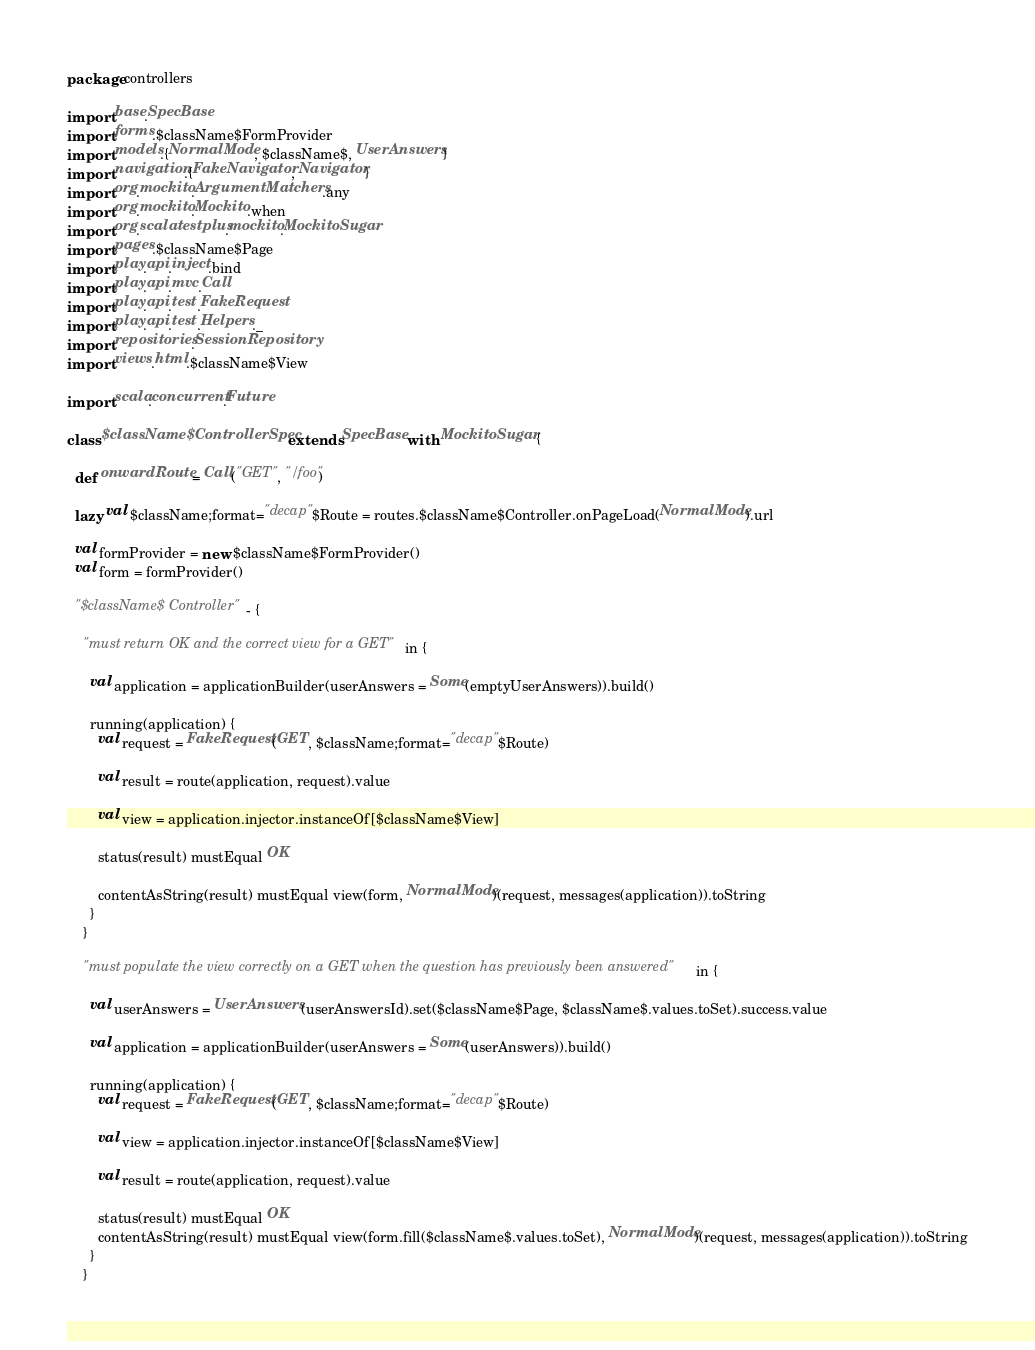<code> <loc_0><loc_0><loc_500><loc_500><_Scala_>package controllers

import base.SpecBase
import forms.$className$FormProvider
import models.{NormalMode, $className$, UserAnswers}
import navigation.{FakeNavigator, Navigator}
import org.mockito.ArgumentMatchers.any
import org.mockito.Mockito.when
import org.scalatestplus.mockito.MockitoSugar
import pages.$className$Page
import play.api.inject.bind
import play.api.mvc.Call
import play.api.test.FakeRequest
import play.api.test.Helpers._
import repositories.SessionRepository
import views.html.$className$View

import scala.concurrent.Future

class $className$ControllerSpec extends SpecBase with MockitoSugar {

  def onwardRoute = Call("GET", "/foo")

  lazy val $className;format="decap"$Route = routes.$className$Controller.onPageLoad(NormalMode).url

  val formProvider = new $className$FormProvider()
  val form = formProvider()

  "$className$ Controller" - {

    "must return OK and the correct view for a GET" in {

      val application = applicationBuilder(userAnswers = Some(emptyUserAnswers)).build()

      running(application) {
        val request = FakeRequest(GET, $className;format="decap"$Route)

        val result = route(application, request).value

        val view = application.injector.instanceOf[$className$View]

        status(result) mustEqual OK

        contentAsString(result) mustEqual view(form, NormalMode)(request, messages(application)).toString
      }
    }

    "must populate the view correctly on a GET when the question has previously been answered" in {

      val userAnswers = UserAnswers(userAnswersId).set($className$Page, $className$.values.toSet).success.value

      val application = applicationBuilder(userAnswers = Some(userAnswers)).build()
      
      running(application) {
        val request = FakeRequest(GET, $className;format="decap"$Route)

        val view = application.injector.instanceOf[$className$View]

        val result = route(application, request).value

        status(result) mustEqual OK
        contentAsString(result) mustEqual view(form.fill($className$.values.toSet), NormalMode)(request, messages(application)).toString
      }
    }
</code> 